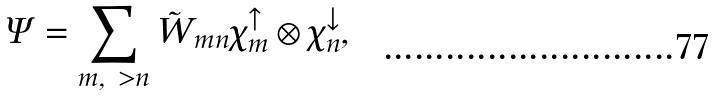<formula> <loc_0><loc_0><loc_500><loc_500>\Psi = \sum _ { m , \ > n } \tilde { W } _ { m n } \chi _ { m } ^ { \uparrow } \otimes \chi _ { n } ^ { \downarrow } ,</formula> 